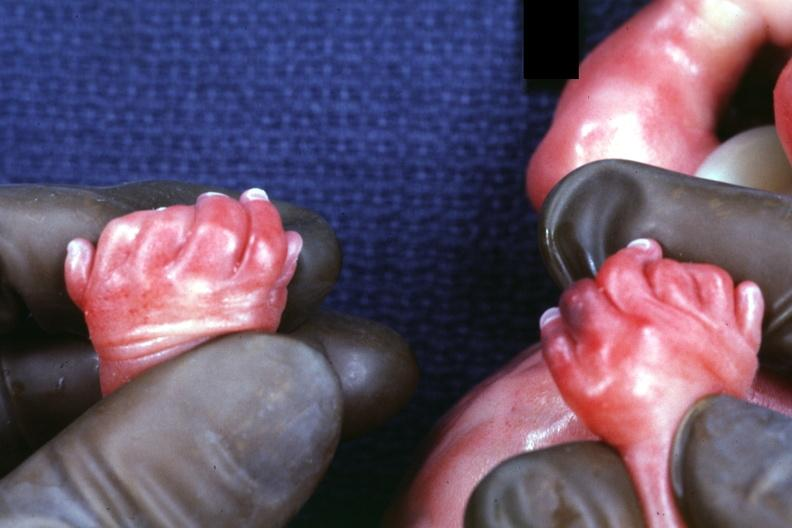what has polycystic disease?
Answer the question using a single word or phrase. No 